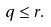Convert formula to latex. <formula><loc_0><loc_0><loc_500><loc_500>q \leq r .</formula> 